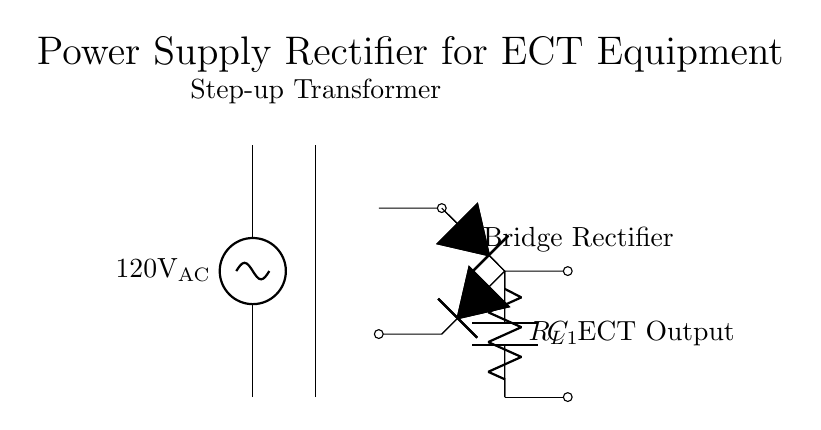What is the input voltage of this circuit? The input voltage is visually indicated at the AC source as 120V.
Answer: 120V What is the role of the transformer in this circuit? The transformer is used to step up the voltage from the AC source prior to rectification.
Answer: Step-up What type of rectifier is used in this circuit? The circuit uses a bridge rectifier, consisting of four diodes arranged to convert AC to DC.
Answer: Bridge What component is responsible for smoothing the output voltage? The smoothing capacitor labeled as C1 in the diagram filters the rectified output to provide a more stable DC voltage.
Answer: C1 How many diodes are there in the rectifier? The bridge rectifier utilizes four diodes to perform the rectification process.
Answer: Four What is the output of the rectifier connected to? The output of the rectifier is connected to the load resistor labeled as R_L for the ECT equipment.
Answer: Load resistor What is the purpose of a bridge rectifier? The bridge rectifier's function is to convert the alternating current from the transformer to direct current for the electroconvulsive therapy equipment.
Answer: Convert AC to DC 